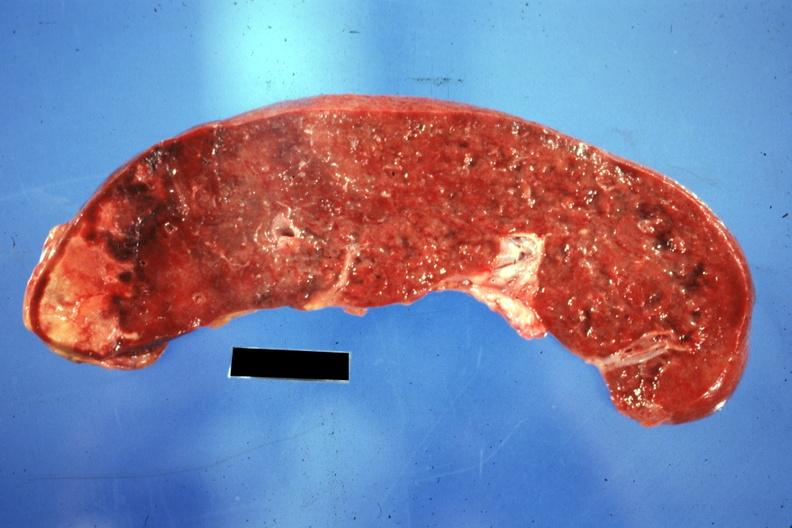s arcus senilis present?
Answer the question using a single word or phrase. No 